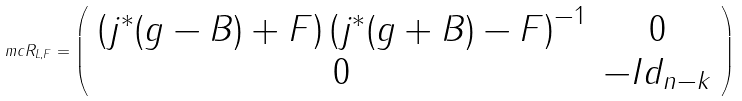Convert formula to latex. <formula><loc_0><loc_0><loc_500><loc_500>\ m c { R } _ { L , F } = \left ( \begin{array} { c c } \left ( j ^ { * } ( g - B ) + F \right ) \left ( j ^ { * } ( g + B ) - F \right ) ^ { - 1 } & 0 \\ 0 & - I d _ { n - k } \end{array} \right )</formula> 